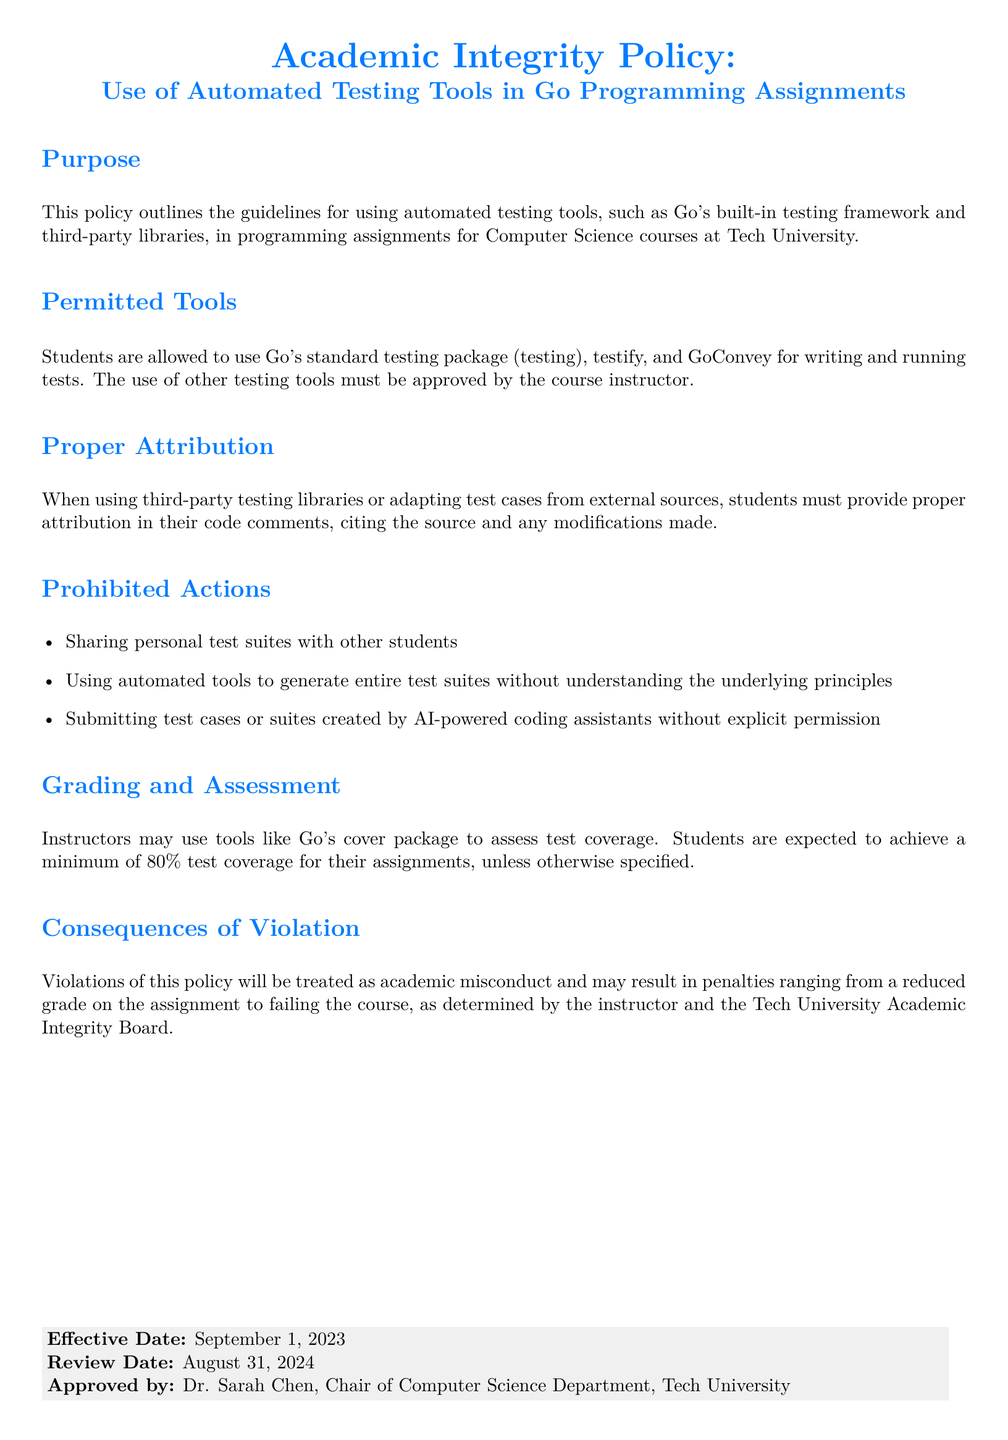What is the purpose of the policy? The purpose section outlines the guidelines for using automated testing tools in programming assignments at Tech University.
Answer: guidelines for using automated testing tools What is the minimum test coverage expected for assignments? The grading and assessment section states that students are expected to achieve a minimum of 80 percent test coverage for their assignments.
Answer: 80 percent Who approved the policy? The document states that Dr. Sarah Chen, Chair of the Computer Science Department, approved the policy.
Answer: Dr. Sarah Chen What are students allowed to use for testing? The permitted tools section states that students are allowed to use Go's standard testing package, testify, and GoConvey for writing and running tests.
Answer: Go's standard testing package, testify, and GoConvey What happens in case of a policy violation? The consequences section mentions that violations will be treated as academic misconduct, resulting in penalties determined by the instructor and the Tech University Academic Integrity Board.
Answer: treated as academic misconduct What is required when using third-party testing libraries? The proper attribution section requires students to provide proper attribution in their code comments, citing the source and any modifications made.
Answer: proper attribution in code comments When is the effective date of the policy? The document specifies that the effective date of the policy is September 1, 2023.
Answer: September 1, 2023 